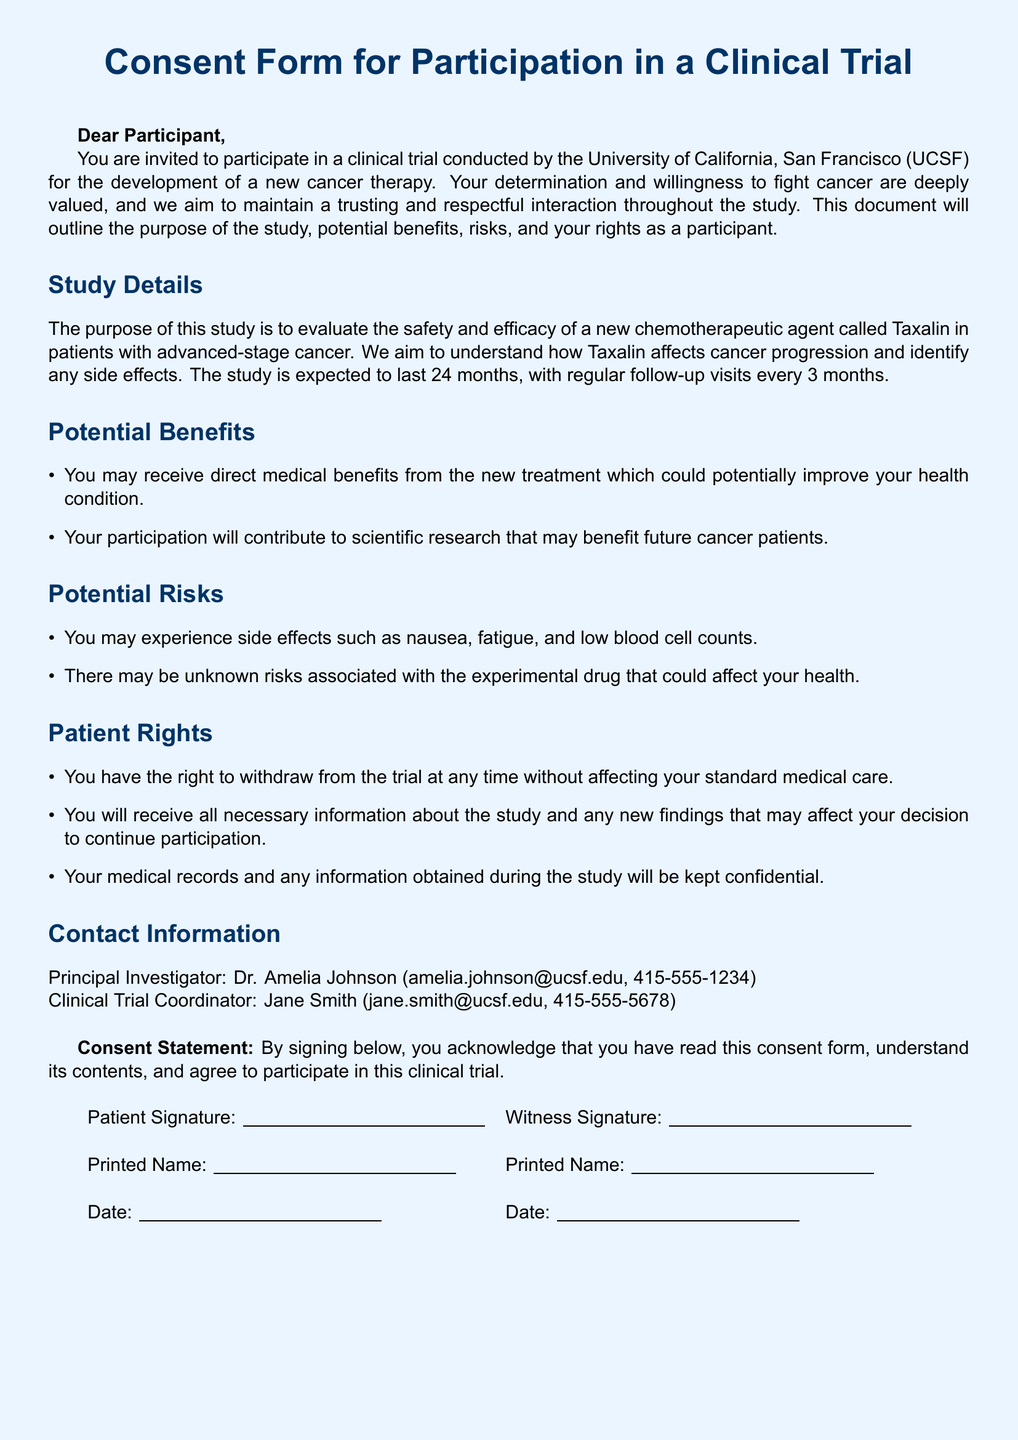What is the name of the new chemotherapeutic agent? The document states that the new chemotherapeutic agent being evaluated is called Taxalin.
Answer: Taxalin How long is the study expected to last? The document mentions that the study is expected to last 24 months.
Answer: 24 months Who is the Principal Investigator? The document provides the name of the Principal Investigator as Dr. Amelia Johnson.
Answer: Dr. Amelia Johnson What are two potential side effects mentioned? The document lists nausea and fatigue as potential side effects of the experimental drug.
Answer: nausea, fatigue What right does a participant have regarding withdrawal from the trial? The document indicates that participants have the right to withdraw from the trial at any time without affecting their standard medical care.
Answer: withdraw at any time How often will follow-up visits occur during the study? The document states that follow-up visits will occur every 3 months.
Answer: every 3 months What is the contact email for the Clinical Trial Coordinator? The document provides the email address of the Clinical Trial Coordinator as jane.smith@ucsf.edu.
Answer: jane.smith@ucsf.edu What must participants acknowledge by signing the consent statement? The document specifies that by signing, participants acknowledge that they have read this consent form and understand its contents.
Answer: read this consent form and understand its contents 